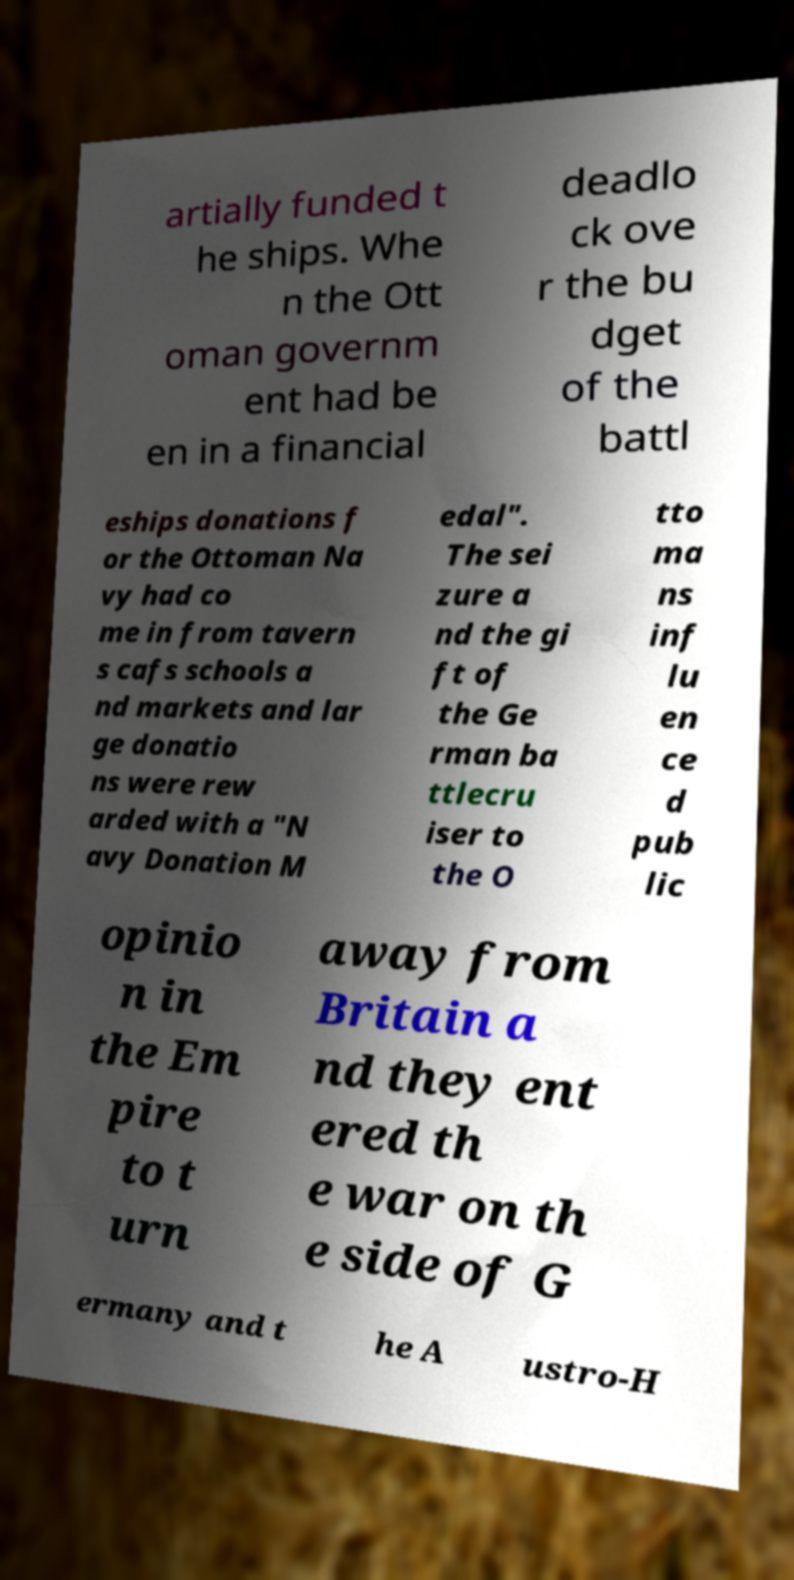Please identify and transcribe the text found in this image. artially funded t he ships. Whe n the Ott oman governm ent had be en in a financial deadlo ck ove r the bu dget of the battl eships donations f or the Ottoman Na vy had co me in from tavern s cafs schools a nd markets and lar ge donatio ns were rew arded with a "N avy Donation M edal". The sei zure a nd the gi ft of the Ge rman ba ttlecru iser to the O tto ma ns inf lu en ce d pub lic opinio n in the Em pire to t urn away from Britain a nd they ent ered th e war on th e side of G ermany and t he A ustro-H 